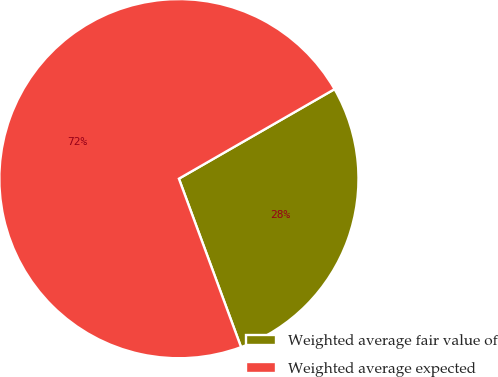Convert chart. <chart><loc_0><loc_0><loc_500><loc_500><pie_chart><fcel>Weighted average fair value of<fcel>Weighted average expected<nl><fcel>27.68%<fcel>72.32%<nl></chart> 